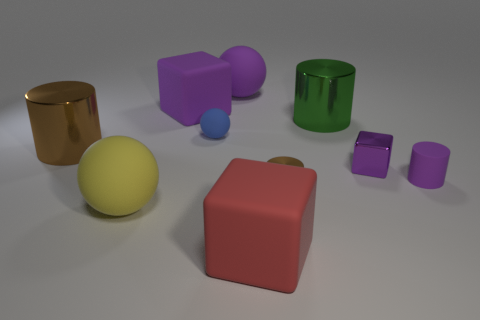What is the shape of the small thing that is the same color as the small rubber cylinder?
Offer a very short reply. Cube. There is a object that is the same color as the small metallic cylinder; what size is it?
Your answer should be very brief. Large. How many other objects are the same shape as the small brown metal object?
Offer a terse response. 3. The purple object that is behind the big purple matte cube has what shape?
Your response must be concise. Sphere. Are there any large red things made of the same material as the blue ball?
Make the answer very short. Yes. There is a large shiny object to the left of the blue rubber sphere; does it have the same color as the small metallic cylinder?
Provide a short and direct response. Yes. What size is the red matte thing?
Your answer should be compact. Large. There is a sphere that is in front of the cylinder that is to the left of the yellow rubber thing; is there a purple thing in front of it?
Your answer should be very brief. No. There is a small metal cylinder; how many tiny purple cubes are in front of it?
Your response must be concise. 0. How many tiny metallic objects are the same color as the tiny block?
Ensure brevity in your answer.  0. 